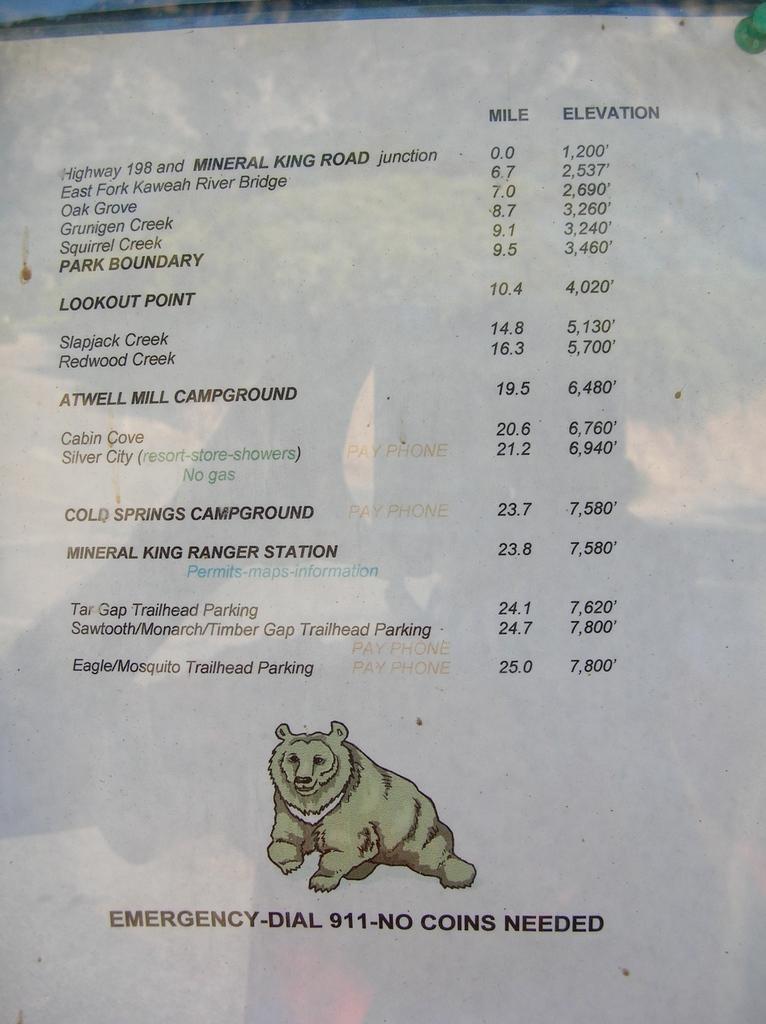How would you summarize this image in a sentence or two? In this image, I can see the words, numbers and a photo of a bear on the paper. 